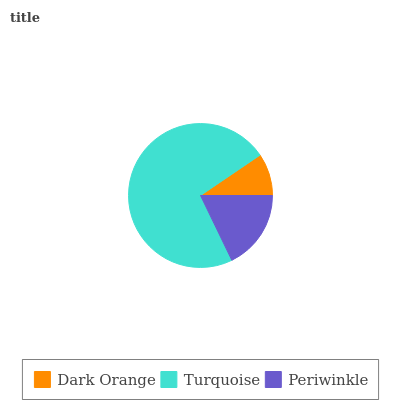Is Dark Orange the minimum?
Answer yes or no. Yes. Is Turquoise the maximum?
Answer yes or no. Yes. Is Periwinkle the minimum?
Answer yes or no. No. Is Periwinkle the maximum?
Answer yes or no. No. Is Turquoise greater than Periwinkle?
Answer yes or no. Yes. Is Periwinkle less than Turquoise?
Answer yes or no. Yes. Is Periwinkle greater than Turquoise?
Answer yes or no. No. Is Turquoise less than Periwinkle?
Answer yes or no. No. Is Periwinkle the high median?
Answer yes or no. Yes. Is Periwinkle the low median?
Answer yes or no. Yes. Is Dark Orange the high median?
Answer yes or no. No. Is Dark Orange the low median?
Answer yes or no. No. 